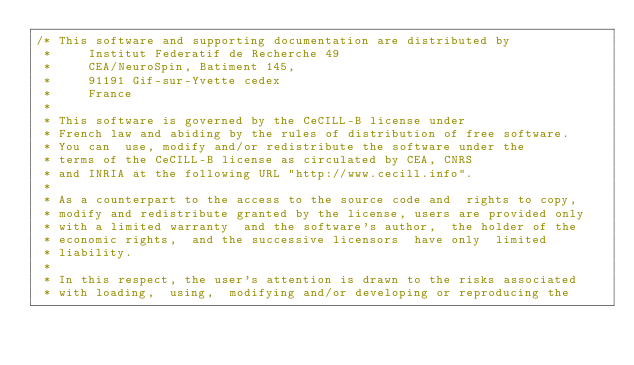<code> <loc_0><loc_0><loc_500><loc_500><_C_>/* This software and supporting documentation are distributed by
 *     Institut Federatif de Recherche 49
 *     CEA/NeuroSpin, Batiment 145,
 *     91191 Gif-sur-Yvette cedex
 *     France
 *
 * This software is governed by the CeCILL-B license under
 * French law and abiding by the rules of distribution of free software.
 * You can  use, modify and/or redistribute the software under the
 * terms of the CeCILL-B license as circulated by CEA, CNRS
 * and INRIA at the following URL "http://www.cecill.info".
 *
 * As a counterpart to the access to the source code and  rights to copy,
 * modify and redistribute granted by the license, users are provided only
 * with a limited warranty  and the software's author,  the holder of the
 * economic rights,  and the successive licensors  have only  limited
 * liability.
 *
 * In this respect, the user's attention is drawn to the risks associated
 * with loading,  using,  modifying and/or developing or reproducing the</code> 